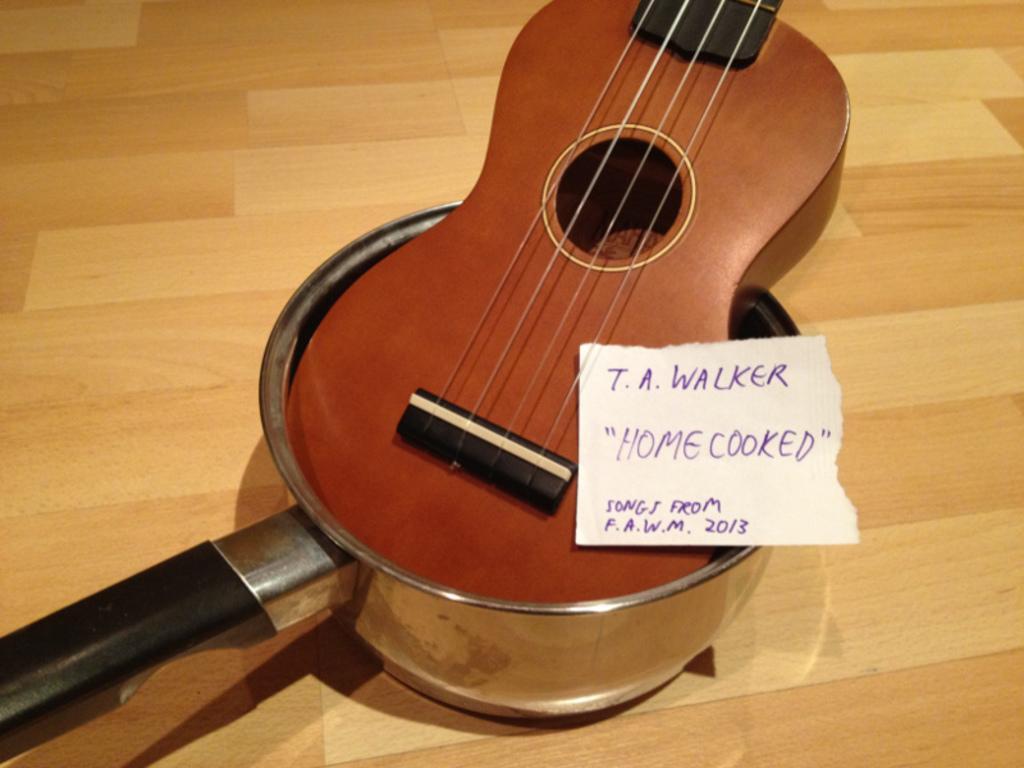Describe this image in one or two sentences. In this image, There is table which is in yellow color and on that table there is a music instrument which is in brown color, There is a pan on the table the handle of pan is in black color. 